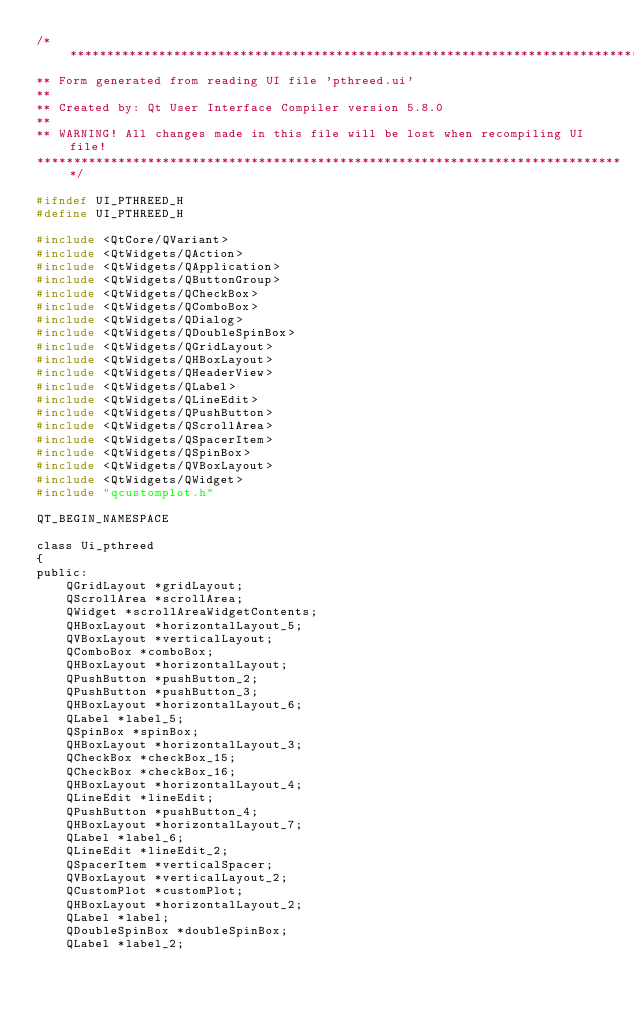Convert code to text. <code><loc_0><loc_0><loc_500><loc_500><_C_>/********************************************************************************
** Form generated from reading UI file 'pthreed.ui'
**
** Created by: Qt User Interface Compiler version 5.8.0
**
** WARNING! All changes made in this file will be lost when recompiling UI file!
********************************************************************************/

#ifndef UI_PTHREED_H
#define UI_PTHREED_H

#include <QtCore/QVariant>
#include <QtWidgets/QAction>
#include <QtWidgets/QApplication>
#include <QtWidgets/QButtonGroup>
#include <QtWidgets/QCheckBox>
#include <QtWidgets/QComboBox>
#include <QtWidgets/QDialog>
#include <QtWidgets/QDoubleSpinBox>
#include <QtWidgets/QGridLayout>
#include <QtWidgets/QHBoxLayout>
#include <QtWidgets/QHeaderView>
#include <QtWidgets/QLabel>
#include <QtWidgets/QLineEdit>
#include <QtWidgets/QPushButton>
#include <QtWidgets/QScrollArea>
#include <QtWidgets/QSpacerItem>
#include <QtWidgets/QSpinBox>
#include <QtWidgets/QVBoxLayout>
#include <QtWidgets/QWidget>
#include "qcustomplot.h"

QT_BEGIN_NAMESPACE

class Ui_pthreed
{
public:
    QGridLayout *gridLayout;
    QScrollArea *scrollArea;
    QWidget *scrollAreaWidgetContents;
    QHBoxLayout *horizontalLayout_5;
    QVBoxLayout *verticalLayout;
    QComboBox *comboBox;
    QHBoxLayout *horizontalLayout;
    QPushButton *pushButton_2;
    QPushButton *pushButton_3;
    QHBoxLayout *horizontalLayout_6;
    QLabel *label_5;
    QSpinBox *spinBox;
    QHBoxLayout *horizontalLayout_3;
    QCheckBox *checkBox_15;
    QCheckBox *checkBox_16;
    QHBoxLayout *horizontalLayout_4;
    QLineEdit *lineEdit;
    QPushButton *pushButton_4;
    QHBoxLayout *horizontalLayout_7;
    QLabel *label_6;
    QLineEdit *lineEdit_2;
    QSpacerItem *verticalSpacer;
    QVBoxLayout *verticalLayout_2;
    QCustomPlot *customPlot;
    QHBoxLayout *horizontalLayout_2;
    QLabel *label;
    QDoubleSpinBox *doubleSpinBox;
    QLabel *label_2;</code> 